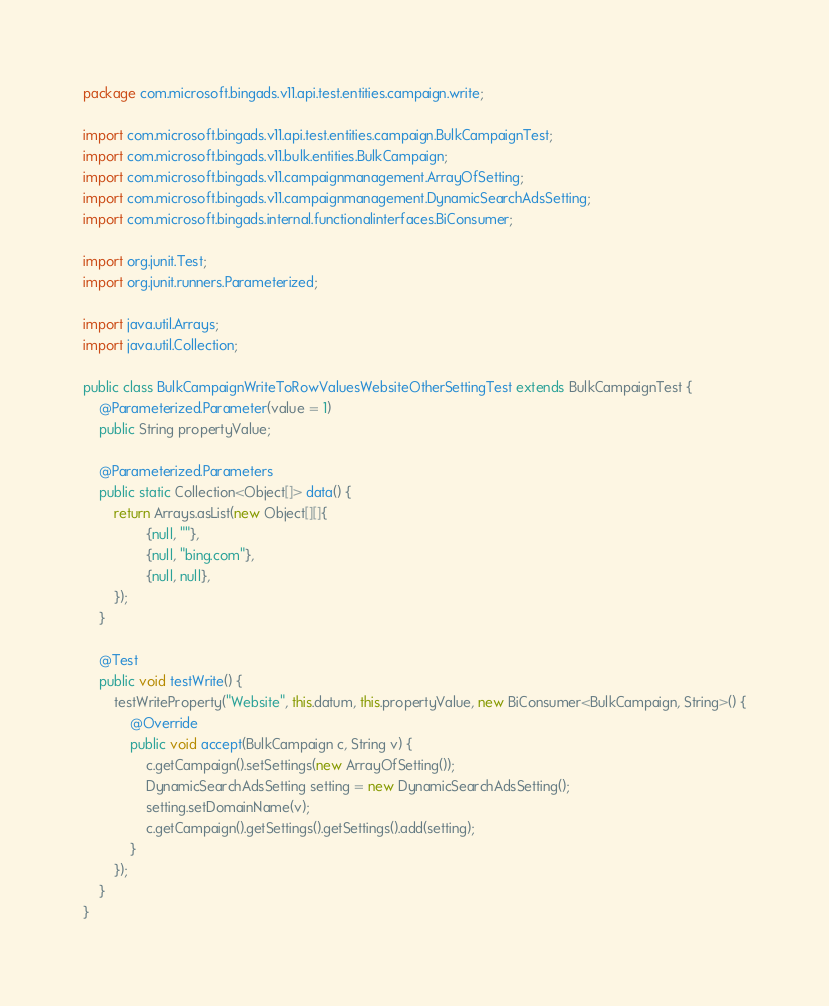<code> <loc_0><loc_0><loc_500><loc_500><_Java_>package com.microsoft.bingads.v11.api.test.entities.campaign.write;

import com.microsoft.bingads.v11.api.test.entities.campaign.BulkCampaignTest;
import com.microsoft.bingads.v11.bulk.entities.BulkCampaign;
import com.microsoft.bingads.v11.campaignmanagement.ArrayOfSetting;
import com.microsoft.bingads.v11.campaignmanagement.DynamicSearchAdsSetting;
import com.microsoft.bingads.internal.functionalinterfaces.BiConsumer;

import org.junit.Test;
import org.junit.runners.Parameterized;

import java.util.Arrays;
import java.util.Collection;

public class BulkCampaignWriteToRowValuesWebsiteOtherSettingTest extends BulkCampaignTest {
    @Parameterized.Parameter(value = 1)
    public String propertyValue;

    @Parameterized.Parameters
    public static Collection<Object[]> data() {
        return Arrays.asList(new Object[][]{
                {null, ""},
                {null, "bing.com"},
                {null, null},
        });
    }

    @Test
    public void testWrite() {
        testWriteProperty("Website", this.datum, this.propertyValue, new BiConsumer<BulkCampaign, String>() {
            @Override
            public void accept(BulkCampaign c, String v) {
                c.getCampaign().setSettings(new ArrayOfSetting());
                DynamicSearchAdsSetting setting = new DynamicSearchAdsSetting();
                setting.setDomainName(v);
                c.getCampaign().getSettings().getSettings().add(setting);
            }
        });
    }
}
</code> 